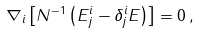Convert formula to latex. <formula><loc_0><loc_0><loc_500><loc_500>\nabla _ { i } \left [ N ^ { - 1 } \left ( E ^ { i } _ { j } - \delta ^ { i } _ { j } E \right ) \right ] = 0 \, ,</formula> 